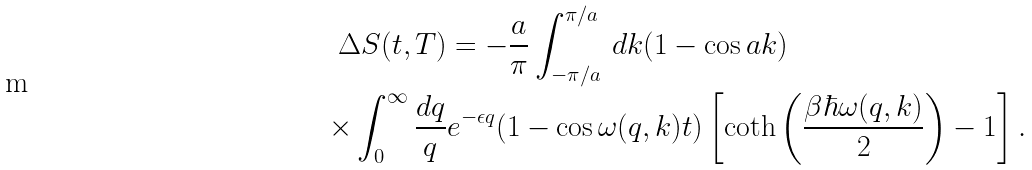Convert formula to latex. <formula><loc_0><loc_0><loc_500><loc_500>\Delta S ( t , T ) & = - \frac { a } { \pi } \int _ { - \pi / a } ^ { \pi / a } \, d k ( 1 - \cos { a k } ) \\ \times \int _ { 0 } ^ { \infty } \frac { d q } { q } & e ^ { - \epsilon q } ( 1 - \cos { \omega ( q , k ) t } ) \left [ \coth { \left ( \frac { \beta \hbar { \omega } ( q , k ) } { 2 } \right ) } - 1 \right ] .</formula> 